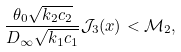<formula> <loc_0><loc_0><loc_500><loc_500>\frac { \theta _ { 0 } \sqrt { k _ { 2 } c _ { 2 } } } { D _ { \infty } \sqrt { k _ { 1 } c _ { 1 } } } \mathcal { J } _ { 3 } ( x ) < \mathcal { M } _ { 2 } ,</formula> 